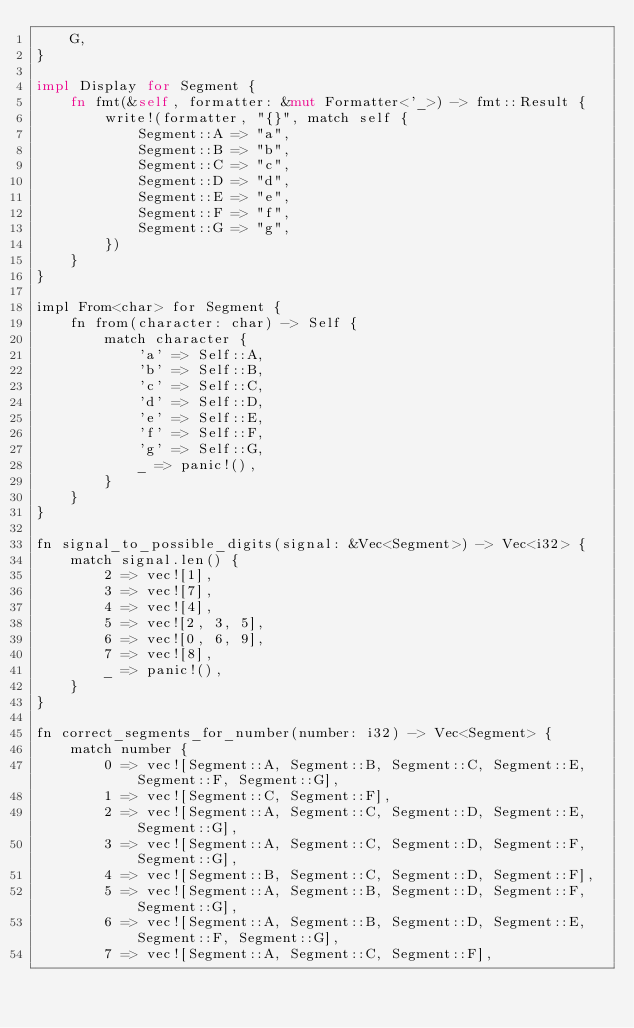<code> <loc_0><loc_0><loc_500><loc_500><_Rust_>    G,
}

impl Display for Segment {
    fn fmt(&self, formatter: &mut Formatter<'_>) -> fmt::Result {
        write!(formatter, "{}", match self {
            Segment::A => "a",
            Segment::B => "b",
            Segment::C => "c",
            Segment::D => "d",
            Segment::E => "e",
            Segment::F => "f",
            Segment::G => "g",
        })
    }
}

impl From<char> for Segment {
    fn from(character: char) -> Self {
        match character {
            'a' => Self::A,
            'b' => Self::B,
            'c' => Self::C,
            'd' => Self::D,
            'e' => Self::E,
            'f' => Self::F,
            'g' => Self::G,
            _ => panic!(),
        }
    }
}

fn signal_to_possible_digits(signal: &Vec<Segment>) -> Vec<i32> {
    match signal.len() {
        2 => vec![1],
        3 => vec![7],
        4 => vec![4],
        5 => vec![2, 3, 5],
        6 => vec![0, 6, 9],
        7 => vec![8],
        _ => panic!(),
    }
}

fn correct_segments_for_number(number: i32) -> Vec<Segment> {
    match number {
        0 => vec![Segment::A, Segment::B, Segment::C, Segment::E, Segment::F, Segment::G],
        1 => vec![Segment::C, Segment::F],
        2 => vec![Segment::A, Segment::C, Segment::D, Segment::E, Segment::G],
        3 => vec![Segment::A, Segment::C, Segment::D, Segment::F, Segment::G],
        4 => vec![Segment::B, Segment::C, Segment::D, Segment::F],
        5 => vec![Segment::A, Segment::B, Segment::D, Segment::F, Segment::G],
        6 => vec![Segment::A, Segment::B, Segment::D, Segment::E, Segment::F, Segment::G],
        7 => vec![Segment::A, Segment::C, Segment::F],</code> 